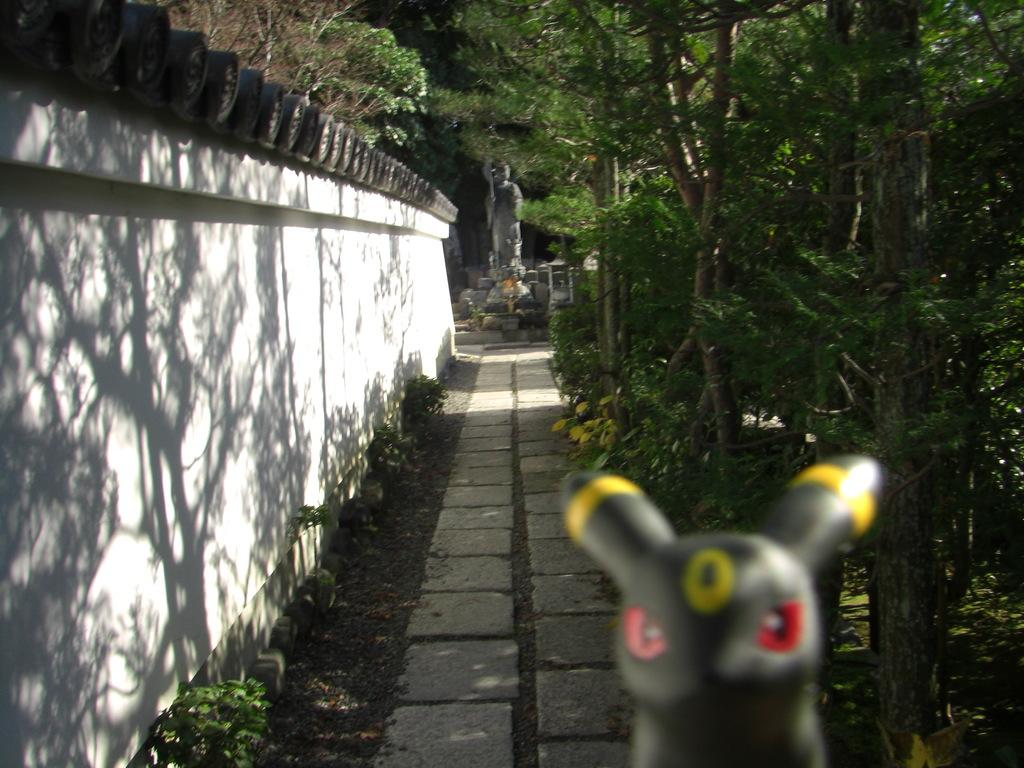What object is located at the bottom of the image? There is a toy at the bottom of the image. What can be seen in the background of the image? There is a statue, trees, and plants in the background of the image. What is on the left side of the image? There is a wall on the left side of the image. What type of whip is being used to get the attention of the pancake in the image? There is no whip, attention, or pancake present in the image. 